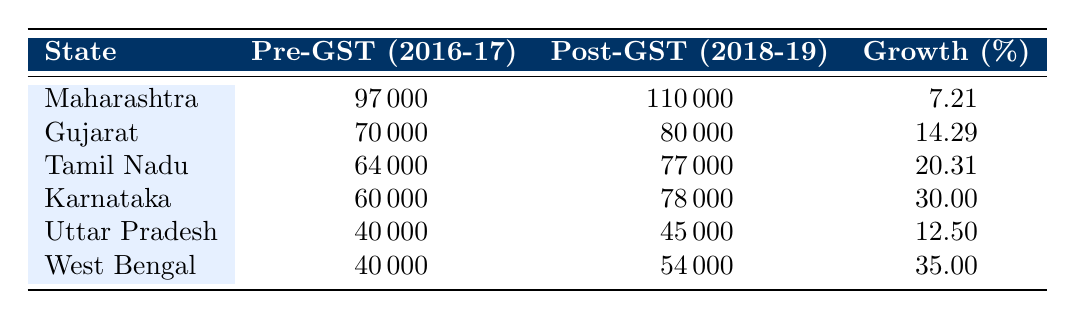What was the post-GST revenue collection for Maharashtra in 2018-19? According to the table, the post-GST revenue collection for Maharashtra in 2018-19 is listed as 110000.
Answer: 110000 Which state experienced the highest revenue growth percentage post-GST? The table shows that West Bengal had the highest revenue growth percentage at 35.00%.
Answer: West Bengal What is the difference in revenue collection for Tamil Nadu before and after GST implementation? The pre-GST collection for Tamil Nadu is 64000 and the post-GST collection is 77000. The difference is 77000 - 64000 = 13000.
Answer: 13000 Is Tamil Nadu's post-GST revenue collection higher than that of Gujarat? Tamil Nadu's post-GST revenue collection is 77000 while Gujarat's is 80000. Since 77000 is less than 80000, the answer is no.
Answer: No What is the average revenue growth percentage of all the states listed? To calculate the average, sum all the revenue growth percentages: 7.21 + 14.29 + 20.31 + 30.00 + 12.50 + 35.00 = 119.31. There are 6 states so the average is 119.31 / 6 = 19.885.
Answer: 19.89 Which two states had revenue collections of 40000 before GST? Looking at the table, both Uttar Pradesh and West Bengal had a pre-GST collection of 40000.
Answer: Uttar Pradesh and West Bengal How much did Karnataka's revenue collection grow in absolute terms after implementing GST? The pre-GST collection for Karnataka was 60000 and the post-GST collection is 78000. The absolute growth is 78000 - 60000 = 18000.
Answer: 18000 Was there any state that had a post-GST revenue collection below 50000? The table indicates that both Uttar Pradesh and West Bengal had post-GST collections of 45000 and 54000, respectively. Since 45000 is below 50000, the answer is yes.
Answer: Yes What is the total revenue collection for all states post-GST? To find the total, add all the post-GST collections: 110000 + 80000 + 77000 + 78000 + 45000 + 54000 = 425000.
Answer: 425000 